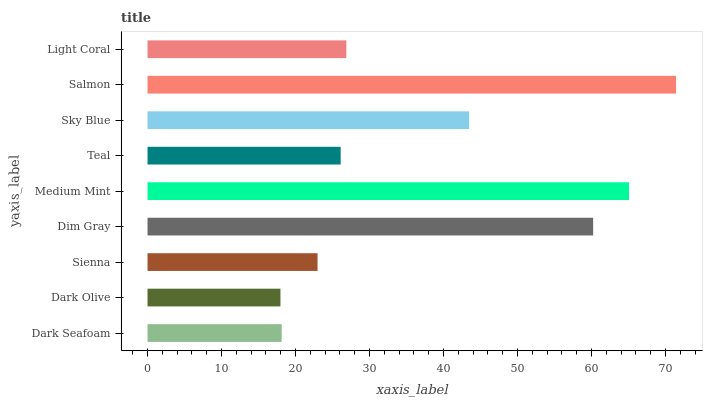Is Dark Olive the minimum?
Answer yes or no. Yes. Is Salmon the maximum?
Answer yes or no. Yes. Is Sienna the minimum?
Answer yes or no. No. Is Sienna the maximum?
Answer yes or no. No. Is Sienna greater than Dark Olive?
Answer yes or no. Yes. Is Dark Olive less than Sienna?
Answer yes or no. Yes. Is Dark Olive greater than Sienna?
Answer yes or no. No. Is Sienna less than Dark Olive?
Answer yes or no. No. Is Light Coral the high median?
Answer yes or no. Yes. Is Light Coral the low median?
Answer yes or no. Yes. Is Sienna the high median?
Answer yes or no. No. Is Salmon the low median?
Answer yes or no. No. 